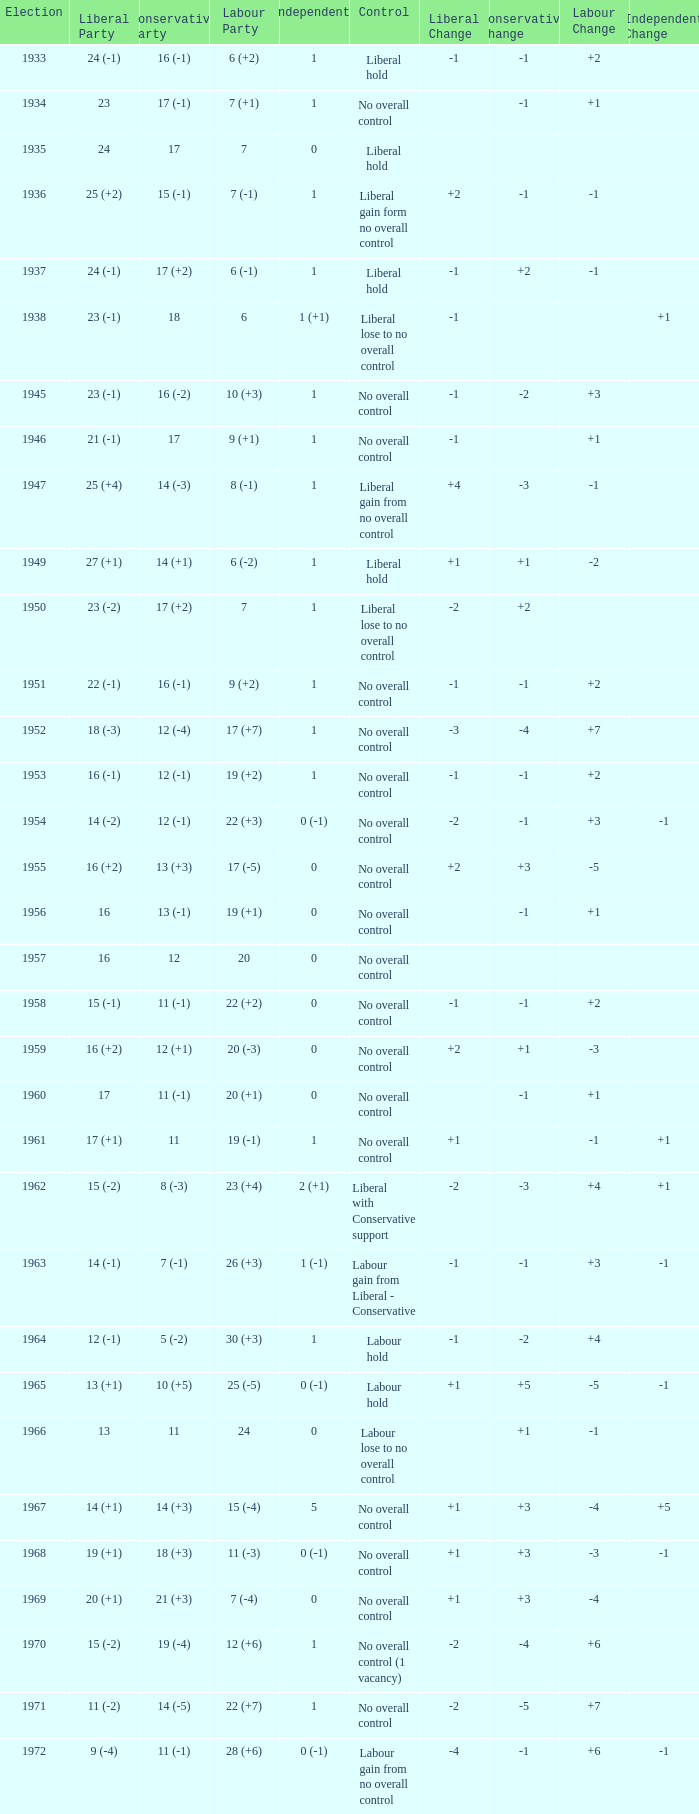What was the Liberal Party result from the election having a Conservative Party result of 16 (-1) and Labour of 6 (+2)? 24 (-1). 